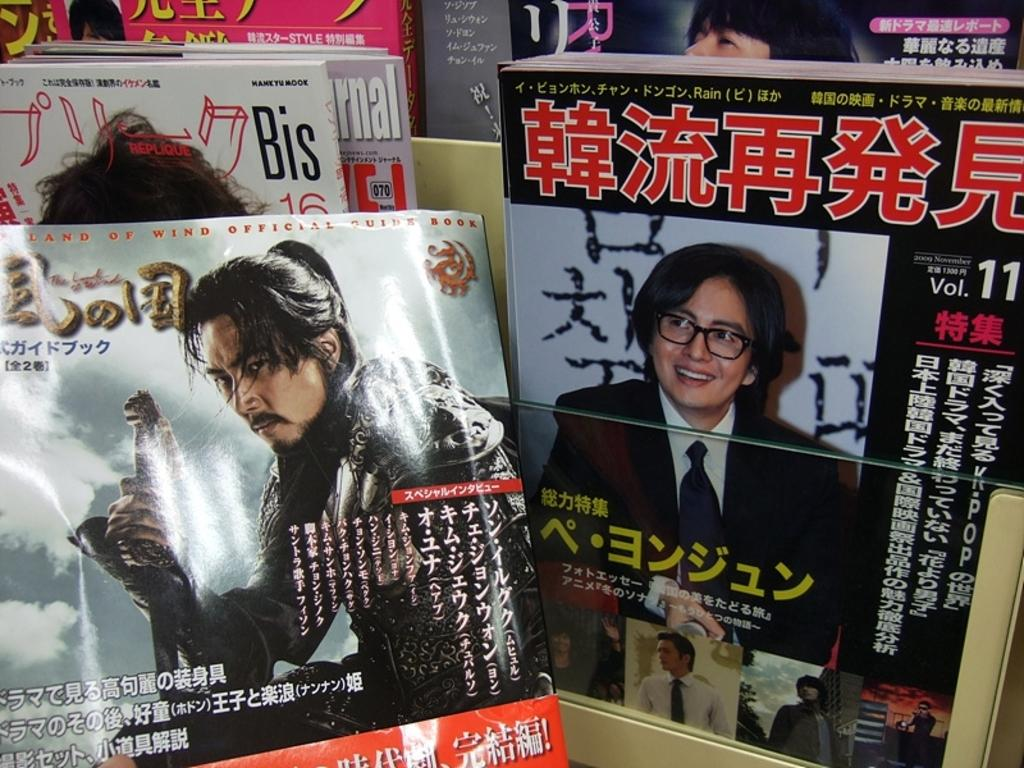What type of objects can be seen in the image? There are objects that appear to be books in the image. What can be observed on the covers of the books? The books have text, numbers, and pictures of people on their covers. Can you describe any other objects present in the image? There are other unspecified objects in the image. How much grain is stored in the cellar depicted in the image? There is no cellar or grain present in the image; it features books with text, numbers, and pictures of people on their covers. 